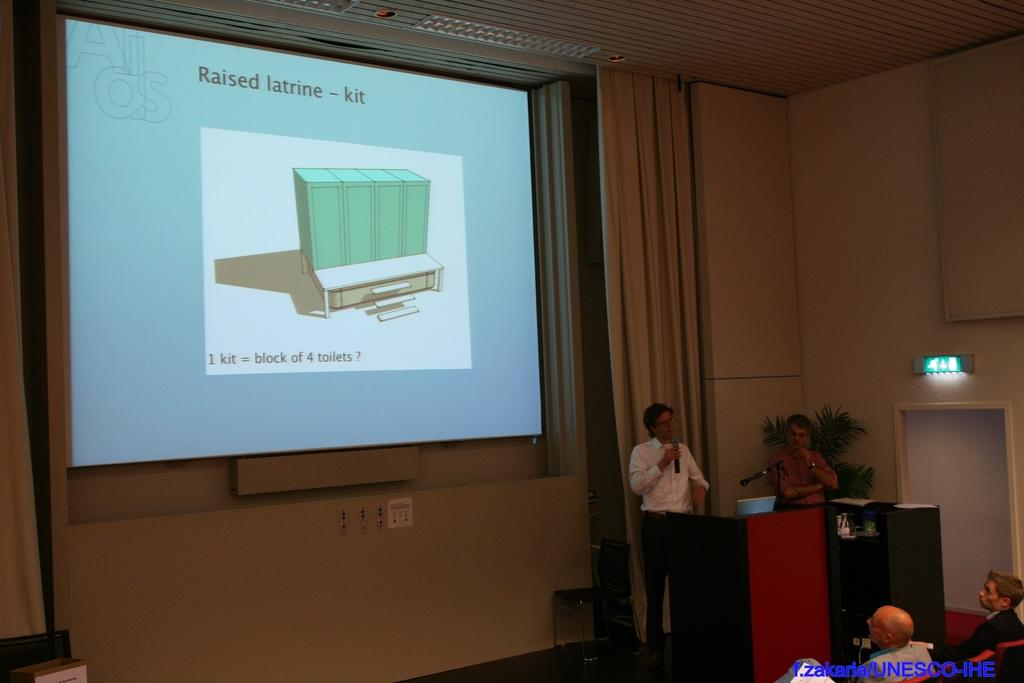<image>
Present a compact description of the photo's key features. A lecturer orates in front of a screen with raised latrine information on it. 